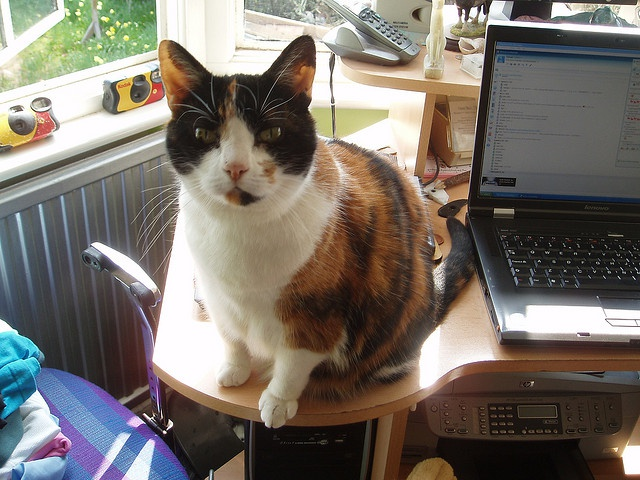Describe the objects in this image and their specific colors. I can see cat in beige, black, maroon, and tan tones, laptop in beige, gray, black, white, and darkgray tones, chair in beige, blue, gray, and white tones, and chair in beige, blue, gray, and lavender tones in this image. 